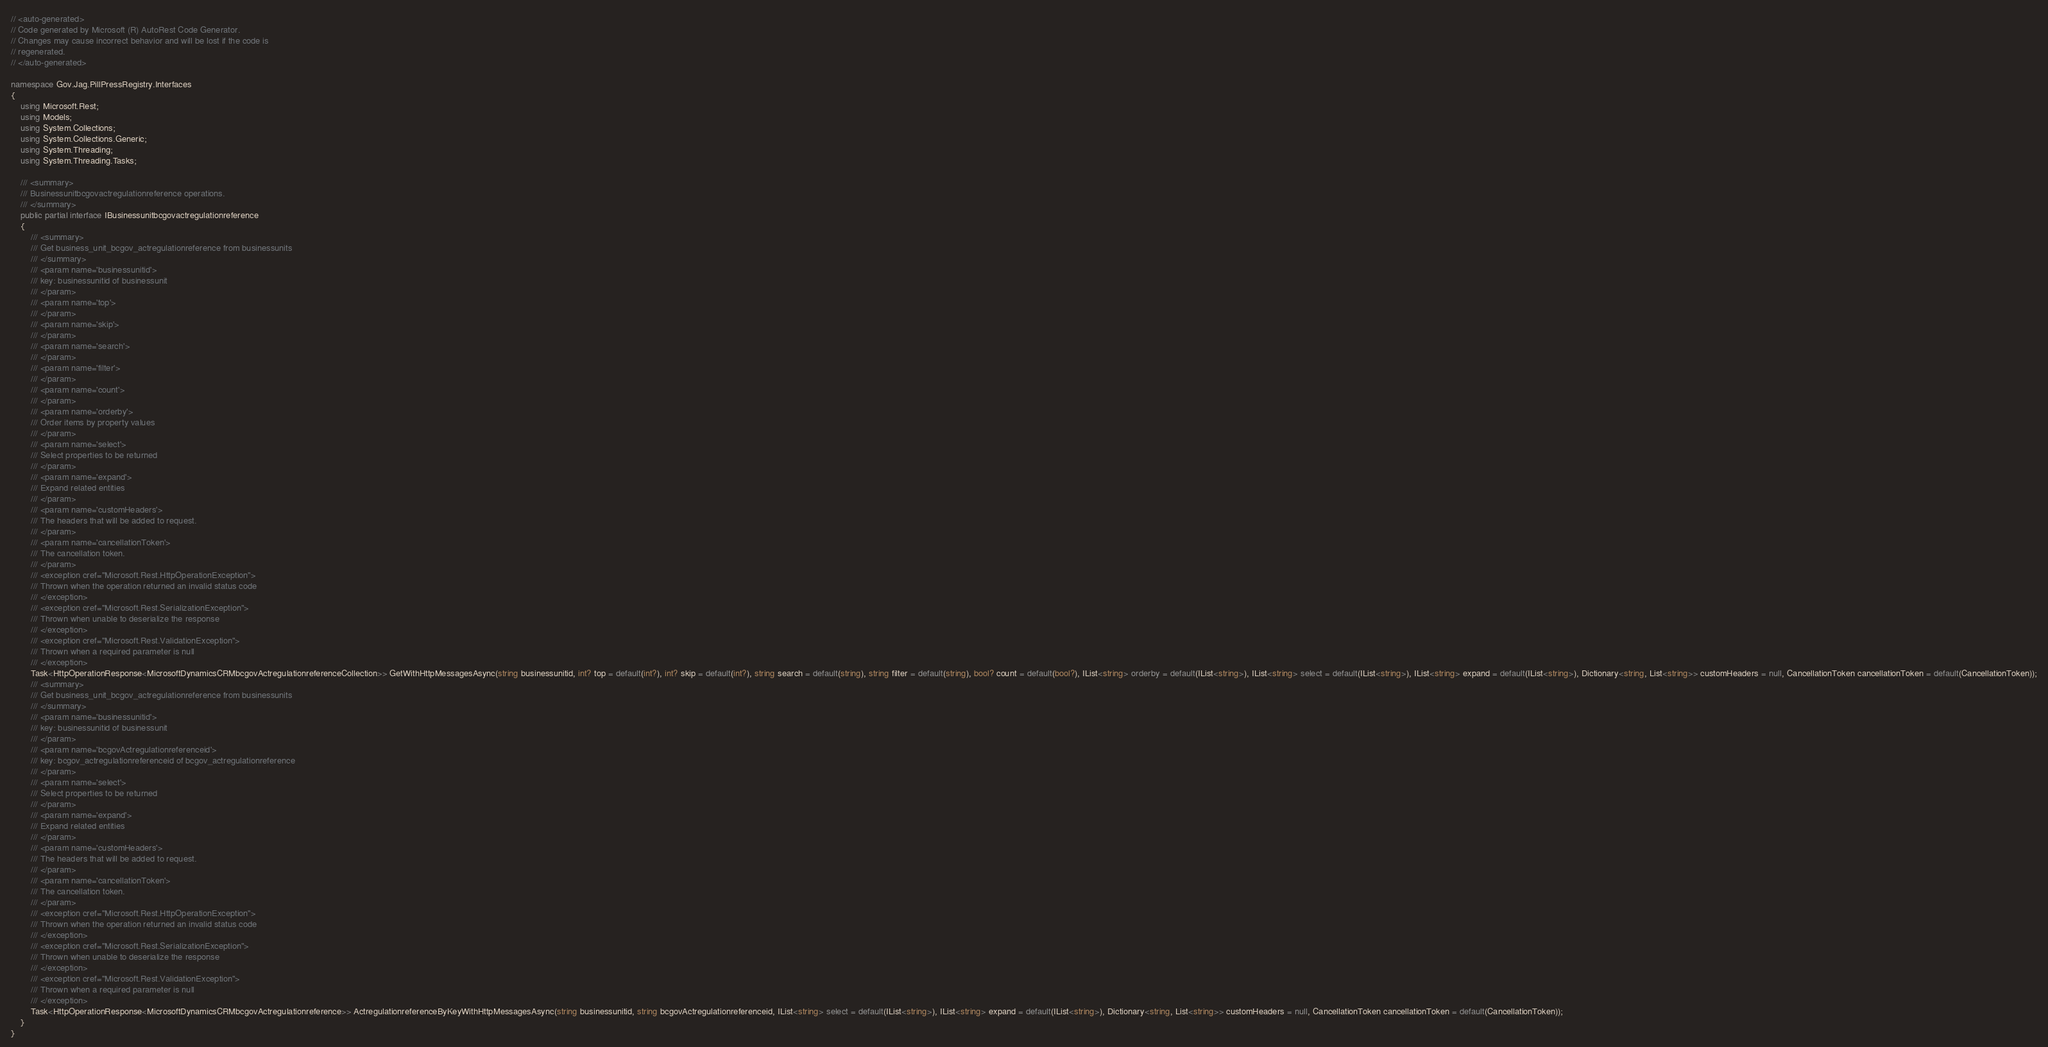<code> <loc_0><loc_0><loc_500><loc_500><_C#_>// <auto-generated>
// Code generated by Microsoft (R) AutoRest Code Generator.
// Changes may cause incorrect behavior and will be lost if the code is
// regenerated.
// </auto-generated>

namespace Gov.Jag.PillPressRegistry.Interfaces
{
    using Microsoft.Rest;
    using Models;
    using System.Collections;
    using System.Collections.Generic;
    using System.Threading;
    using System.Threading.Tasks;

    /// <summary>
    /// Businessunitbcgovactregulationreference operations.
    /// </summary>
    public partial interface IBusinessunitbcgovactregulationreference
    {
        /// <summary>
        /// Get business_unit_bcgov_actregulationreference from businessunits
        /// </summary>
        /// <param name='businessunitid'>
        /// key: businessunitid of businessunit
        /// </param>
        /// <param name='top'>
        /// </param>
        /// <param name='skip'>
        /// </param>
        /// <param name='search'>
        /// </param>
        /// <param name='filter'>
        /// </param>
        /// <param name='count'>
        /// </param>
        /// <param name='orderby'>
        /// Order items by property values
        /// </param>
        /// <param name='select'>
        /// Select properties to be returned
        /// </param>
        /// <param name='expand'>
        /// Expand related entities
        /// </param>
        /// <param name='customHeaders'>
        /// The headers that will be added to request.
        /// </param>
        /// <param name='cancellationToken'>
        /// The cancellation token.
        /// </param>
        /// <exception cref="Microsoft.Rest.HttpOperationException">
        /// Thrown when the operation returned an invalid status code
        /// </exception>
        /// <exception cref="Microsoft.Rest.SerializationException">
        /// Thrown when unable to deserialize the response
        /// </exception>
        /// <exception cref="Microsoft.Rest.ValidationException">
        /// Thrown when a required parameter is null
        /// </exception>
        Task<HttpOperationResponse<MicrosoftDynamicsCRMbcgovActregulationreferenceCollection>> GetWithHttpMessagesAsync(string businessunitid, int? top = default(int?), int? skip = default(int?), string search = default(string), string filter = default(string), bool? count = default(bool?), IList<string> orderby = default(IList<string>), IList<string> select = default(IList<string>), IList<string> expand = default(IList<string>), Dictionary<string, List<string>> customHeaders = null, CancellationToken cancellationToken = default(CancellationToken));
        /// <summary>
        /// Get business_unit_bcgov_actregulationreference from businessunits
        /// </summary>
        /// <param name='businessunitid'>
        /// key: businessunitid of businessunit
        /// </param>
        /// <param name='bcgovActregulationreferenceid'>
        /// key: bcgov_actregulationreferenceid of bcgov_actregulationreference
        /// </param>
        /// <param name='select'>
        /// Select properties to be returned
        /// </param>
        /// <param name='expand'>
        /// Expand related entities
        /// </param>
        /// <param name='customHeaders'>
        /// The headers that will be added to request.
        /// </param>
        /// <param name='cancellationToken'>
        /// The cancellation token.
        /// </param>
        /// <exception cref="Microsoft.Rest.HttpOperationException">
        /// Thrown when the operation returned an invalid status code
        /// </exception>
        /// <exception cref="Microsoft.Rest.SerializationException">
        /// Thrown when unable to deserialize the response
        /// </exception>
        /// <exception cref="Microsoft.Rest.ValidationException">
        /// Thrown when a required parameter is null
        /// </exception>
        Task<HttpOperationResponse<MicrosoftDynamicsCRMbcgovActregulationreference>> ActregulationreferenceByKeyWithHttpMessagesAsync(string businessunitid, string bcgovActregulationreferenceid, IList<string> select = default(IList<string>), IList<string> expand = default(IList<string>), Dictionary<string, List<string>> customHeaders = null, CancellationToken cancellationToken = default(CancellationToken));
    }
}
</code> 